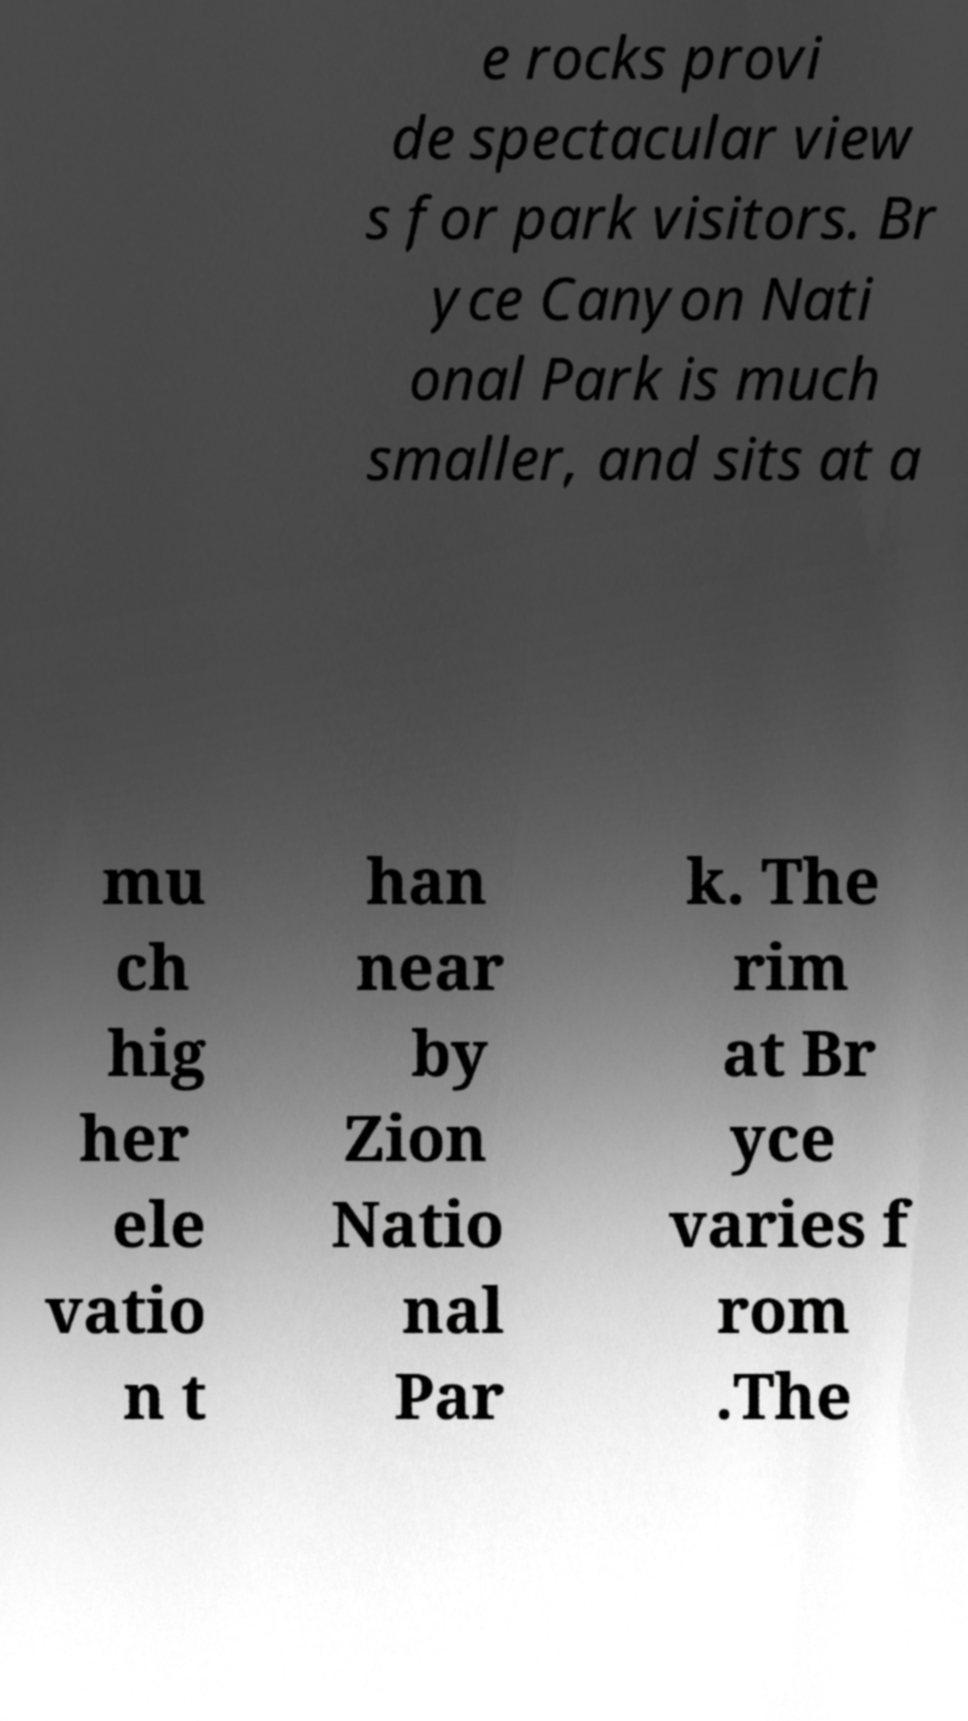Could you extract and type out the text from this image? e rocks provi de spectacular view s for park visitors. Br yce Canyon Nati onal Park is much smaller, and sits at a mu ch hig her ele vatio n t han near by Zion Natio nal Par k. The rim at Br yce varies f rom .The 